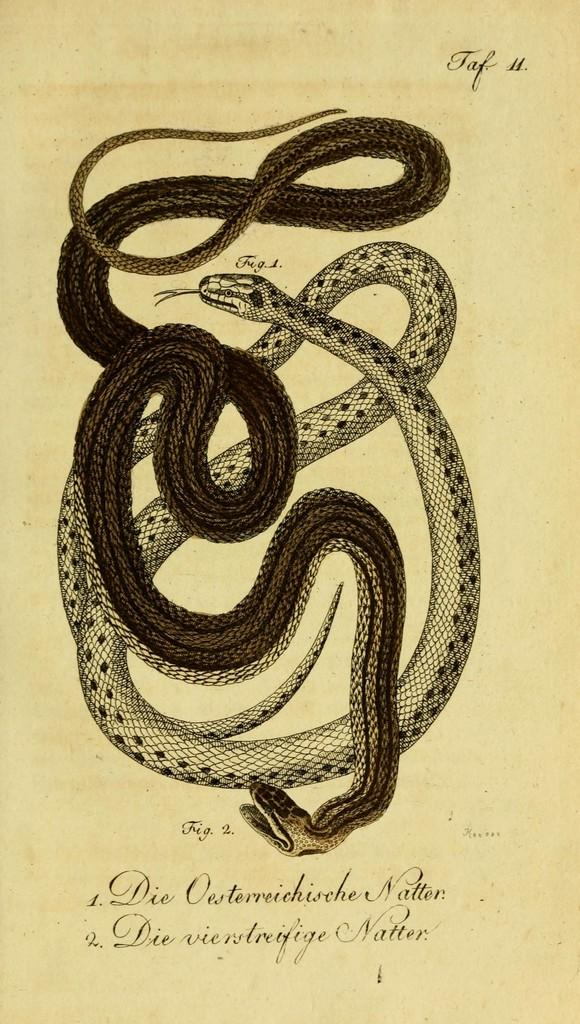What is depicted on the poster in the image? The poster features a snake. What else can be seen on the poster besides the snake? There is text written on the poster. What type of bean is growing in the field shown in the image? There is no field or bean present in the image; it features a poster with a snake and text. 